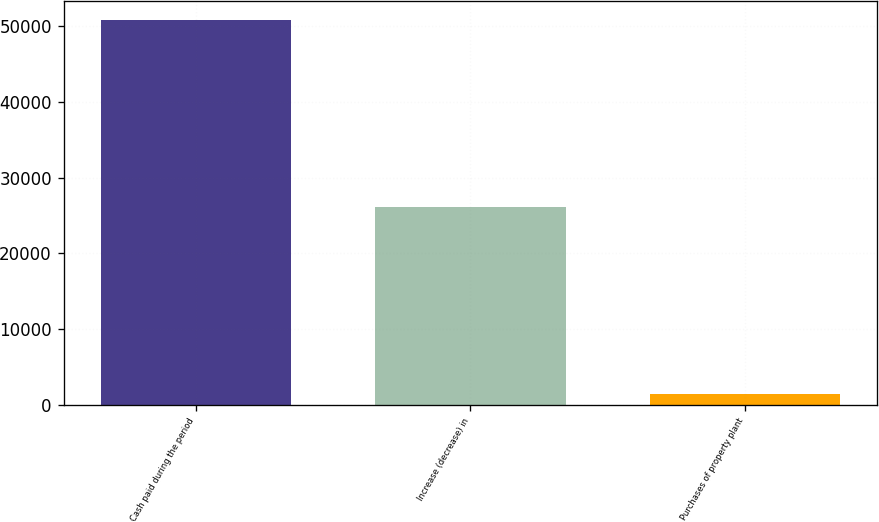<chart> <loc_0><loc_0><loc_500><loc_500><bar_chart><fcel>Cash paid during the period<fcel>Increase (decrease) in<fcel>Purchases of property plant<nl><fcel>50861.4<fcel>26150.2<fcel>1439<nl></chart> 